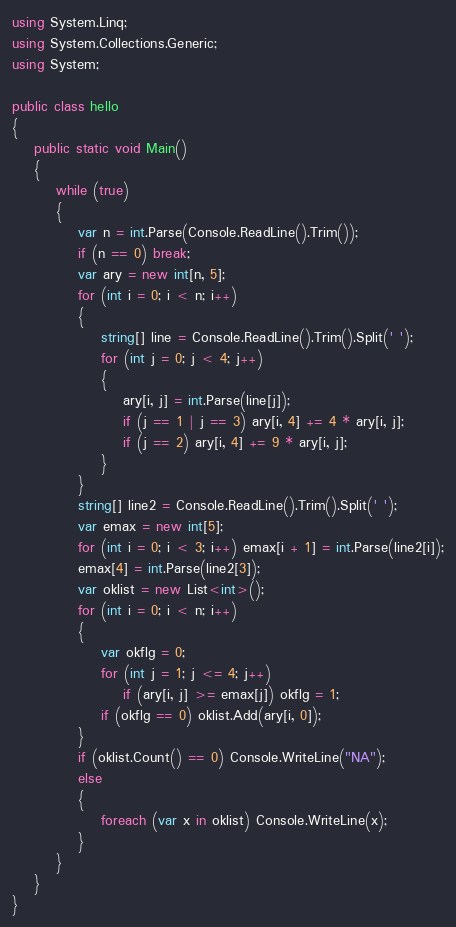<code> <loc_0><loc_0><loc_500><loc_500><_C#_>using System.Linq;
using System.Collections.Generic;
using System;

public class hello
{
    public static void Main()
    {
        while (true)
        {
            var n = int.Parse(Console.ReadLine().Trim());
            if (n == 0) break;
            var ary = new int[n, 5];
            for (int i = 0; i < n; i++)
            {
                string[] line = Console.ReadLine().Trim().Split(' ');
                for (int j = 0; j < 4; j++)
                {
                    ary[i, j] = int.Parse(line[j]);
                    if (j == 1 | j == 3) ary[i, 4] += 4 * ary[i, j];
                    if (j == 2) ary[i, 4] += 9 * ary[i, j];
                }
            }
            string[] line2 = Console.ReadLine().Trim().Split(' ');
            var emax = new int[5];
            for (int i = 0; i < 3; i++) emax[i + 1] = int.Parse(line2[i]);
            emax[4] = int.Parse(line2[3]);
            var oklist = new List<int>();
            for (int i = 0; i < n; i++)
            {
                var okflg = 0;
                for (int j = 1; j <= 4; j++)
                    if (ary[i, j] >= emax[j]) okflg = 1;
                if (okflg == 0) oklist.Add(ary[i, 0]);
            }
            if (oklist.Count() == 0) Console.WriteLine("NA");
            else
            {
                foreach (var x in oklist) Console.WriteLine(x);
            }
        }
    }
}</code> 